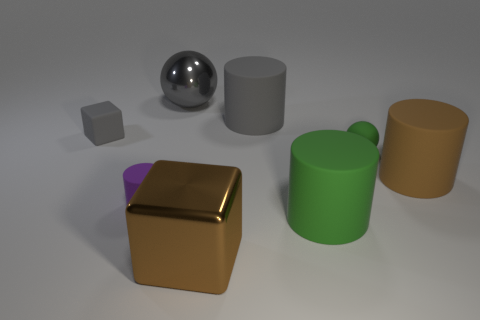Subtract all big cylinders. How many cylinders are left? 1 Add 1 brown blocks. How many objects exist? 9 Subtract all purple cylinders. How many cylinders are left? 3 Subtract all brown blocks. How many green cylinders are left? 1 Subtract all balls. How many objects are left? 6 Subtract 2 balls. How many balls are left? 0 Add 6 big balls. How many big balls are left? 7 Add 7 large green things. How many large green things exist? 8 Subtract 0 blue blocks. How many objects are left? 8 Subtract all yellow balls. Subtract all red blocks. How many balls are left? 2 